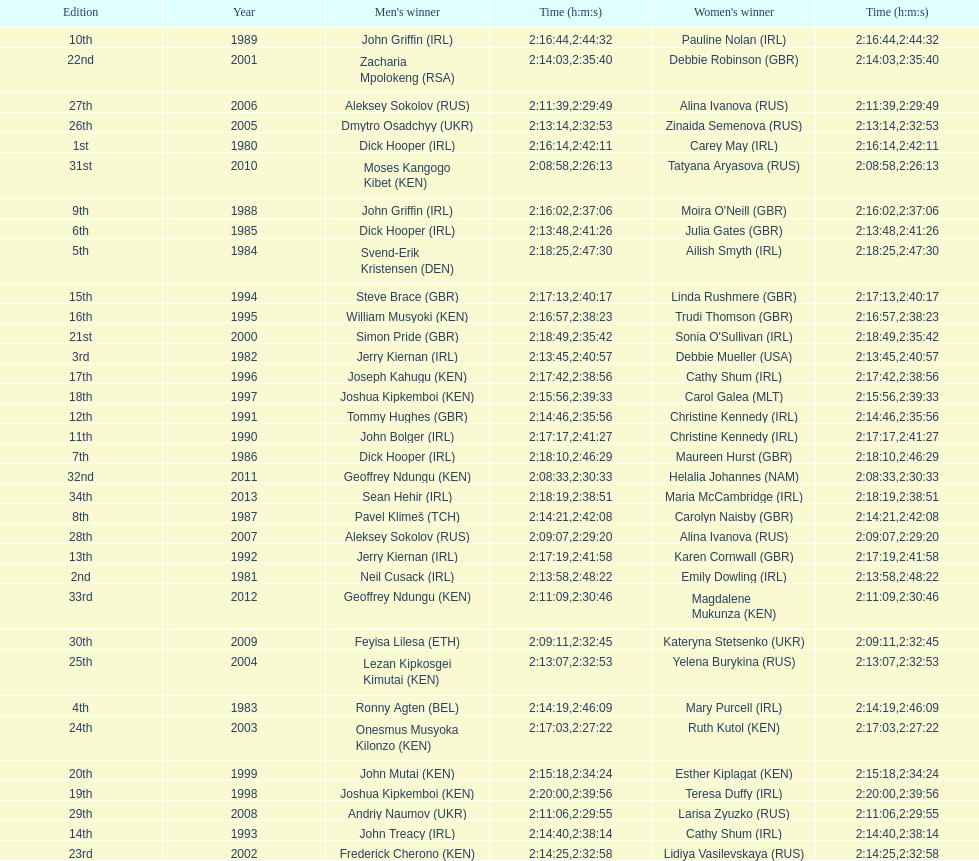How many women's winners are from kenya? 3. 